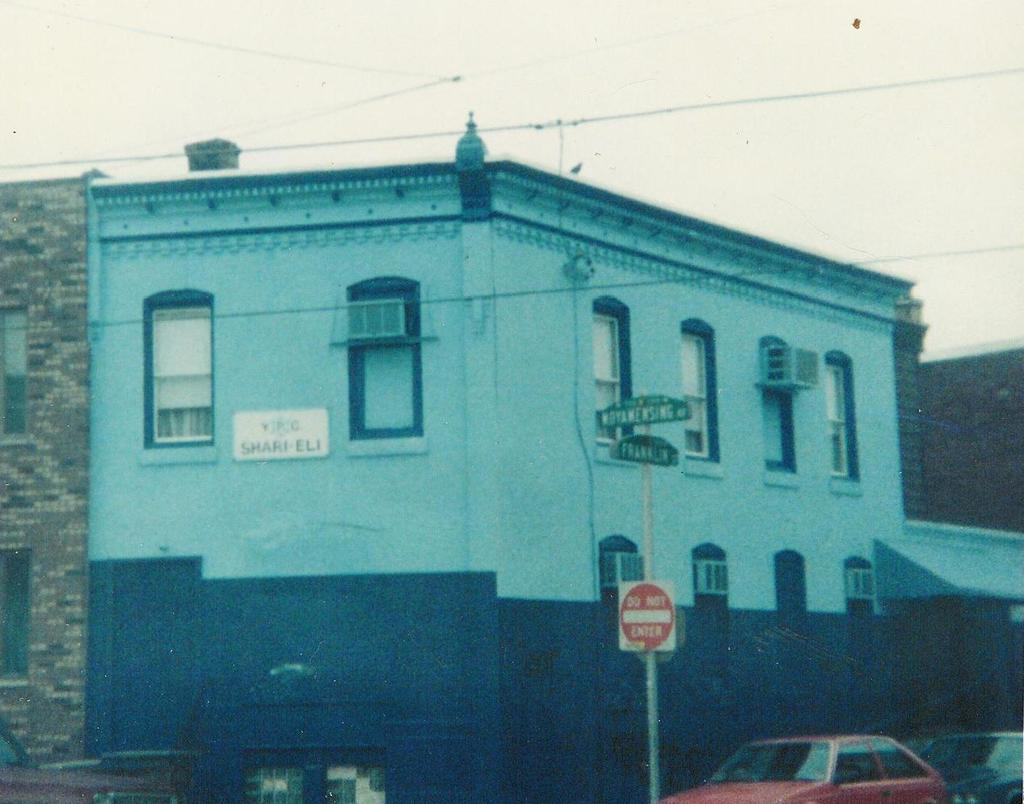<image>
Render a clear and concise summary of the photo. A "Do Not Enter" sign is next to a blue and black building. 